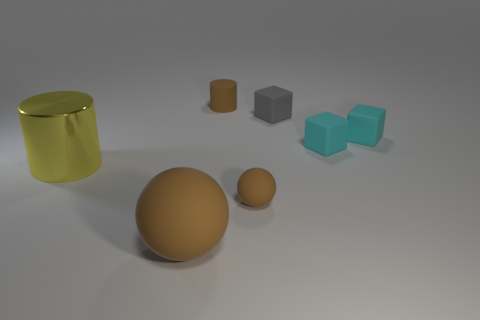Add 1 cylinders. How many objects exist? 8 Subtract all cylinders. How many objects are left? 5 Add 7 tiny brown things. How many tiny brown things are left? 9 Add 1 big red rubber spheres. How many big red rubber spheres exist? 1 Subtract 0 purple blocks. How many objects are left? 7 Subtract all blue shiny cubes. Subtract all large objects. How many objects are left? 5 